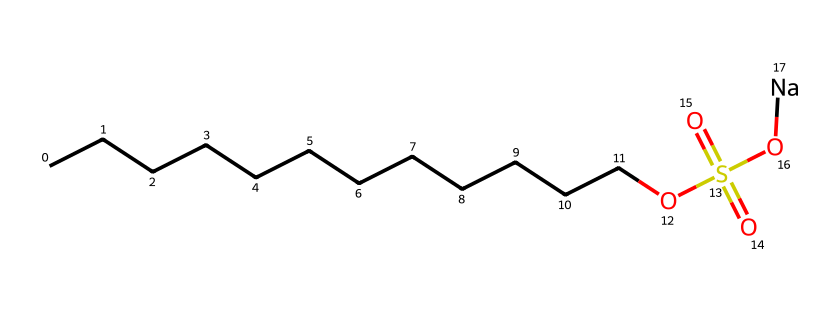What is the total number of carbon atoms in this molecule? The SMILES shows a long chain of carbon atoms (C). Counting the "C" symbols before the "O" yields 12 carbon atoms in the linear alkyl chain.
Answer: 12 What functional group is present in this chemical structure? The presence of the "OS(=O)(=O)" segment indicates a sulfonate group, specifically, the sulfonic acid derivative attached to a sodium ion (Na).
Answer: sulfonate How many oxygen atoms are in this chemical? By analyzing the SMILES representation, there are four oxygen atoms present: one in the "O," two in the sulfonate (OS(=O)(=O)), and one more in the hydroxyl group (-O).
Answer: 4 Is this a polar or non-polar molecule? Given the presence of the sulfonate group which is highly polar and the long hydrophobic carbon chain, the overall structure is polar due to the polar sulfonate group dominating.
Answer: polar What role does the sodium ion play in this chemical? The sodium ion (Na) in this compound usually serves to balance the charge of the sulfonate group, making the molecule soluble in water, enhancing its effectiveness as a lubricant.
Answer: charge balance How does the long carbon chain affect the properties of dish soap? The long carbon chain contributes to the hydrophobic properties, allowing the soap to interact with oils and grease, effectively helping in cleaning and lubrication, which is key to its usage.
Answer: hydrophobic properties 